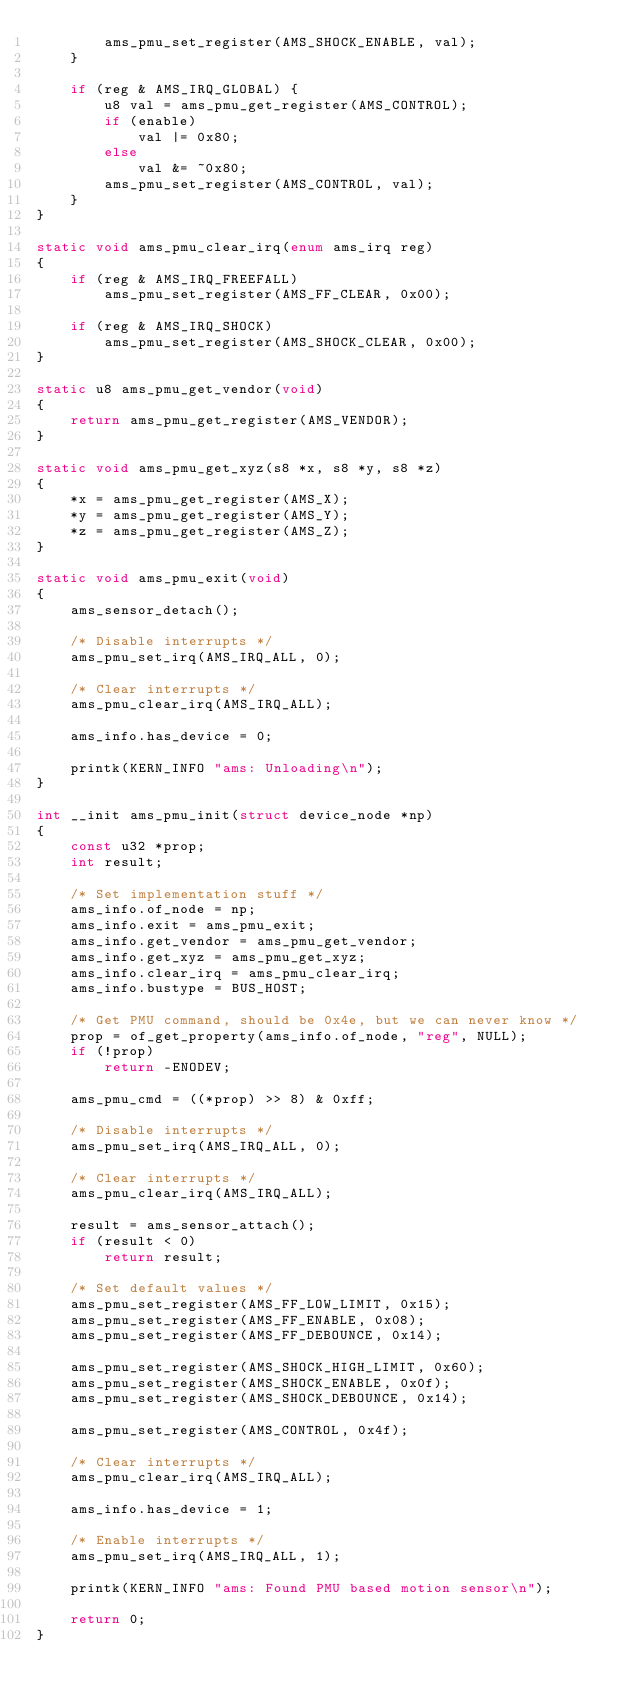Convert code to text. <code><loc_0><loc_0><loc_500><loc_500><_C_>		ams_pmu_set_register(AMS_SHOCK_ENABLE, val);
	}

	if (reg & AMS_IRQ_GLOBAL) {
		u8 val = ams_pmu_get_register(AMS_CONTROL);
		if (enable)
			val |= 0x80;
		else
			val &= ~0x80;
		ams_pmu_set_register(AMS_CONTROL, val);
	}
}

static void ams_pmu_clear_irq(enum ams_irq reg)
{
	if (reg & AMS_IRQ_FREEFALL)
		ams_pmu_set_register(AMS_FF_CLEAR, 0x00);

	if (reg & AMS_IRQ_SHOCK)
		ams_pmu_set_register(AMS_SHOCK_CLEAR, 0x00);
}

static u8 ams_pmu_get_vendor(void)
{
	return ams_pmu_get_register(AMS_VENDOR);
}

static void ams_pmu_get_xyz(s8 *x, s8 *y, s8 *z)
{
	*x = ams_pmu_get_register(AMS_X);
	*y = ams_pmu_get_register(AMS_Y);
	*z = ams_pmu_get_register(AMS_Z);
}

static void ams_pmu_exit(void)
{
	ams_sensor_detach();

	/* Disable interrupts */
	ams_pmu_set_irq(AMS_IRQ_ALL, 0);

	/* Clear interrupts */
	ams_pmu_clear_irq(AMS_IRQ_ALL);

	ams_info.has_device = 0;

	printk(KERN_INFO "ams: Unloading\n");
}

int __init ams_pmu_init(struct device_node *np)
{
	const u32 *prop;
	int result;

	/* Set implementation stuff */
	ams_info.of_node = np;
	ams_info.exit = ams_pmu_exit;
	ams_info.get_vendor = ams_pmu_get_vendor;
	ams_info.get_xyz = ams_pmu_get_xyz;
	ams_info.clear_irq = ams_pmu_clear_irq;
	ams_info.bustype = BUS_HOST;

	/* Get PMU command, should be 0x4e, but we can never know */
	prop = of_get_property(ams_info.of_node, "reg", NULL);
	if (!prop)
		return -ENODEV;

	ams_pmu_cmd = ((*prop) >> 8) & 0xff;

	/* Disable interrupts */
	ams_pmu_set_irq(AMS_IRQ_ALL, 0);

	/* Clear interrupts */
	ams_pmu_clear_irq(AMS_IRQ_ALL);

	result = ams_sensor_attach();
	if (result < 0)
		return result;

	/* Set default values */
	ams_pmu_set_register(AMS_FF_LOW_LIMIT, 0x15);
	ams_pmu_set_register(AMS_FF_ENABLE, 0x08);
	ams_pmu_set_register(AMS_FF_DEBOUNCE, 0x14);

	ams_pmu_set_register(AMS_SHOCK_HIGH_LIMIT, 0x60);
	ams_pmu_set_register(AMS_SHOCK_ENABLE, 0x0f);
	ams_pmu_set_register(AMS_SHOCK_DEBOUNCE, 0x14);

	ams_pmu_set_register(AMS_CONTROL, 0x4f);

	/* Clear interrupts */
	ams_pmu_clear_irq(AMS_IRQ_ALL);

	ams_info.has_device = 1;

	/* Enable interrupts */
	ams_pmu_set_irq(AMS_IRQ_ALL, 1);

	printk(KERN_INFO "ams: Found PMU based motion sensor\n");

	return 0;
}
</code> 